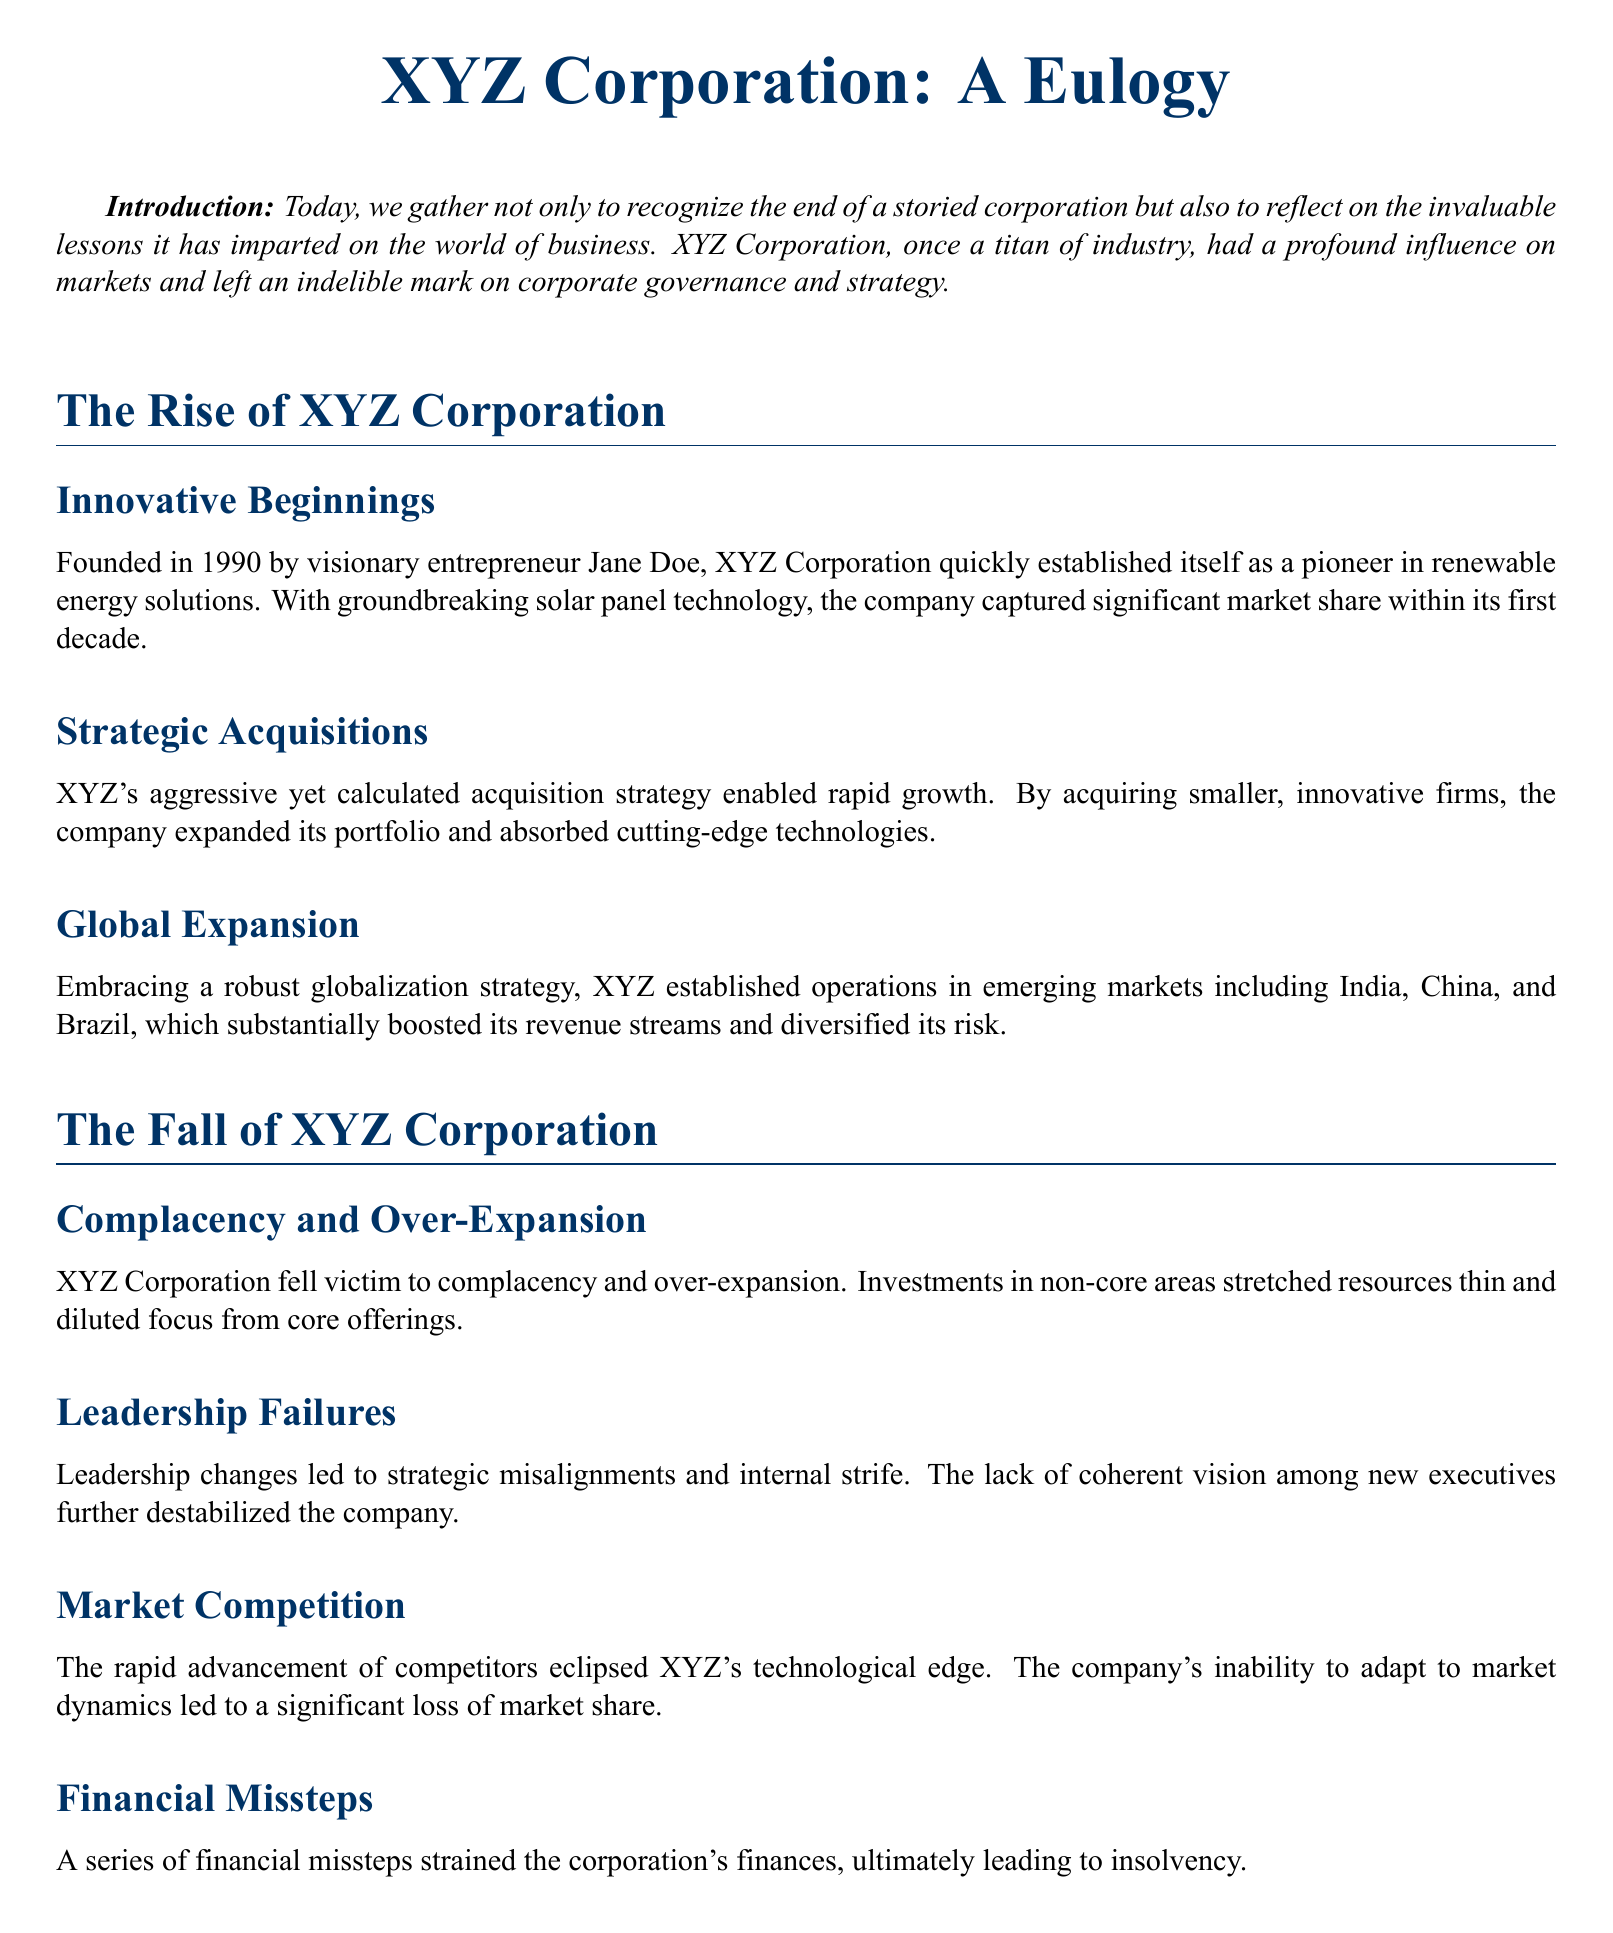What year was XYZ Corporation founded? The document states that XYZ Corporation was founded in 1990.
Answer: 1990 Who was the founder of XYZ Corporation? The document mentions Jane Doe as the founder of XYZ Corporation.
Answer: Jane Doe What was a key strategy for XYZ's growth? The document highlights aggressive acquisitions as a key strategy for XYZ's growth.
Answer: Strategic Acquisitions What caused XYZ's market share loss? The document points to the rapid advancement of competitors as the cause of XYZ's market share loss.
Answer: Market Competition What is one lesson learned from XYZ Corporation's fall? The document lists embracing adaptive leadership as a significant lesson learned.
Answer: Embrace Adaptive Leadership How did XYZ Corporation's leadership changes affect the company? The document indicates that changes in leadership led to strategic misalignments and internal strife.
Answer: Leadership Failures What should future corporations focus on for financial stability? The document recommends prioritizing sustainable growth strategies for financial stability.
Answer: Sustainable Growth Strategies What type of corporate culture should be built according to the recommendations? The document advises building a resilient corporate culture.
Answer: Resilient Corporate Culture What did XYZ Corporation primarily innovate in? The document states that XYZ Corporation was a pioneer in renewable energy solutions.
Answer: Renewable energy solutions 